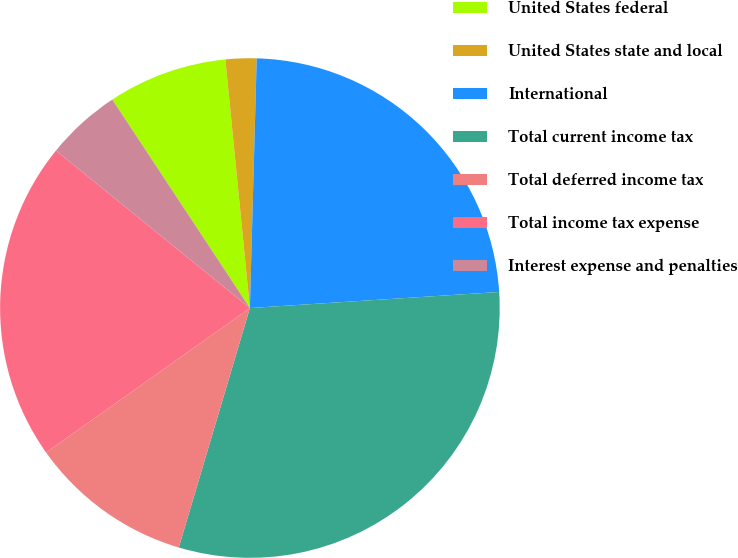Convert chart. <chart><loc_0><loc_0><loc_500><loc_500><pie_chart><fcel>United States federal<fcel>United States state and local<fcel>International<fcel>Total current income tax<fcel>Total deferred income tax<fcel>Total income tax expense<fcel>Interest expense and penalties<nl><fcel>7.72%<fcel>2.0%<fcel>23.54%<fcel>30.62%<fcel>10.59%<fcel>20.67%<fcel>4.86%<nl></chart> 